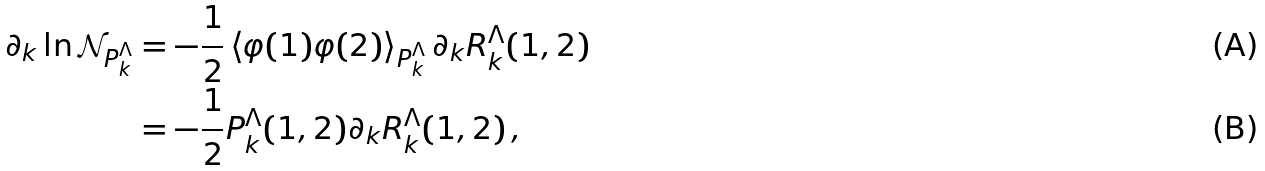Convert formula to latex. <formula><loc_0><loc_0><loc_500><loc_500>\partial _ { k } \ln \mathcal { N } _ { P ^ { \Lambda } _ { k } } & = - \frac { 1 } { 2 } \left \langle \varphi ( 1 ) \varphi ( 2 ) \right \rangle _ { P ^ { \Lambda } _ { k } } \partial _ { k } R ^ { \Lambda } _ { k } ( 1 , 2 ) \\ & = - \frac { 1 } { 2 } P ^ { \Lambda } _ { k } ( 1 , 2 ) \partial _ { k } R ^ { \Lambda } _ { k } ( 1 , 2 ) \, ,</formula> 